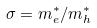Convert formula to latex. <formula><loc_0><loc_0><loc_500><loc_500>\sigma = m _ { e } ^ { * } / m _ { h } ^ { * }</formula> 